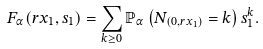Convert formula to latex. <formula><loc_0><loc_0><loc_500><loc_500>F _ { \alpha } ( r x _ { 1 } , s _ { 1 } ) = \sum _ { k \geq 0 } \mathbb { P } _ { \alpha } \left ( N _ { ( 0 , r x _ { 1 } ) } = k \right ) s _ { 1 } ^ { k } .</formula> 